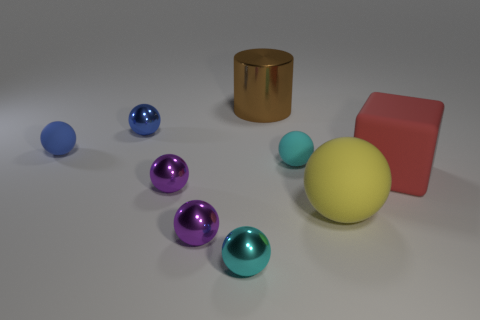Are there any other blue metallic things of the same shape as the big metallic thing?
Your answer should be compact. No. Is the color of the block the same as the cylinder?
Your answer should be very brief. No. Are there any red rubber things to the right of the tiny purple sphere that is behind the large yellow matte sphere?
Your answer should be very brief. Yes. How many things are matte spheres that are right of the big brown cylinder or small metal spheres that are behind the big red rubber block?
Provide a short and direct response. 3. How many objects are either brown blocks or matte things to the right of the small cyan metal thing?
Provide a short and direct response. 3. How big is the purple metallic thing that is in front of the purple ball behind the big rubber object that is left of the big rubber block?
Your answer should be very brief. Small. What is the material of the yellow ball that is the same size as the red thing?
Offer a very short reply. Rubber. Are there any green metal cylinders of the same size as the blue rubber ball?
Your answer should be compact. No. Does the shiny ball that is behind the cyan rubber thing have the same size as the cyan matte sphere?
Offer a very short reply. Yes. There is a rubber object that is behind the big red rubber thing and to the right of the small blue metal ball; what shape is it?
Provide a succinct answer. Sphere. 